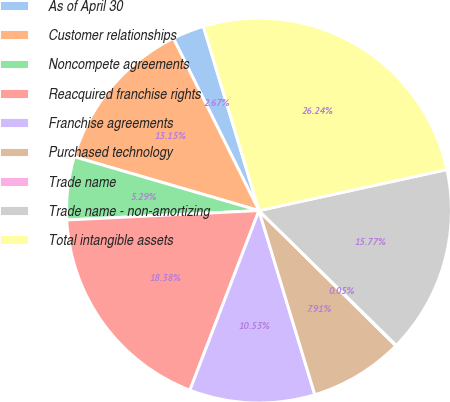Convert chart to OTSL. <chart><loc_0><loc_0><loc_500><loc_500><pie_chart><fcel>As of April 30<fcel>Customer relationships<fcel>Noncompete agreements<fcel>Reacquired franchise rights<fcel>Franchise agreements<fcel>Purchased technology<fcel>Trade name<fcel>Trade name - non-amortizing<fcel>Total intangible assets<nl><fcel>2.67%<fcel>13.15%<fcel>5.29%<fcel>18.38%<fcel>10.53%<fcel>7.91%<fcel>0.05%<fcel>15.77%<fcel>26.24%<nl></chart> 